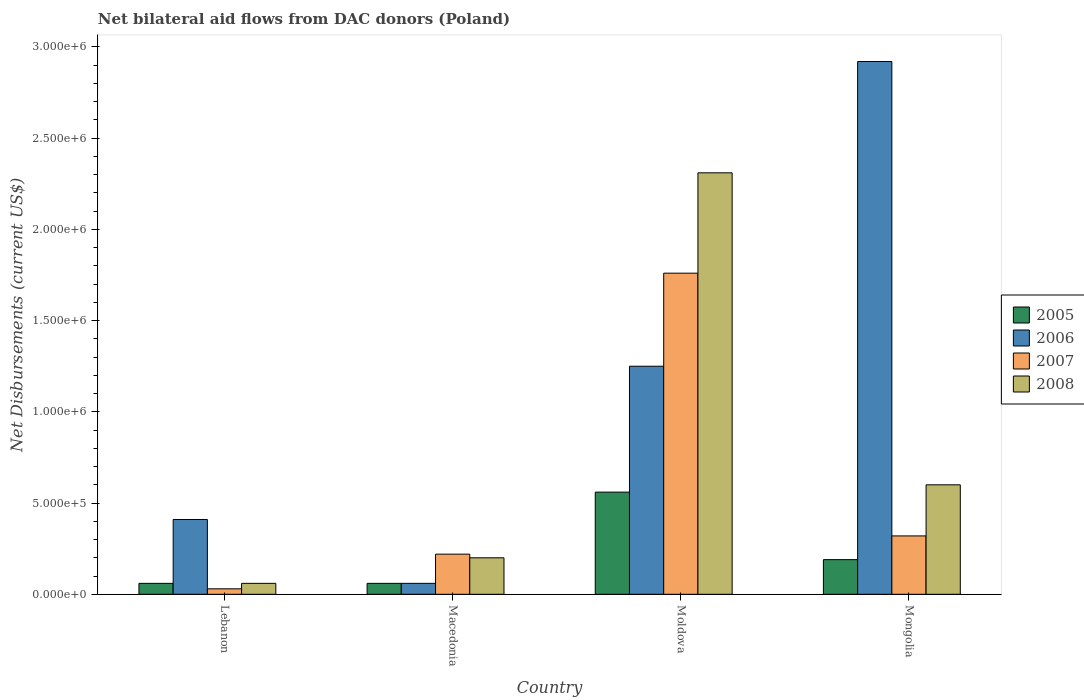How many groups of bars are there?
Offer a very short reply. 4. Are the number of bars on each tick of the X-axis equal?
Provide a succinct answer. Yes. How many bars are there on the 1st tick from the right?
Provide a short and direct response. 4. What is the label of the 3rd group of bars from the left?
Keep it short and to the point. Moldova. What is the net bilateral aid flows in 2008 in Macedonia?
Keep it short and to the point. 2.00e+05. Across all countries, what is the maximum net bilateral aid flows in 2007?
Your answer should be very brief. 1.76e+06. In which country was the net bilateral aid flows in 2008 maximum?
Provide a short and direct response. Moldova. In which country was the net bilateral aid flows in 2007 minimum?
Give a very brief answer. Lebanon. What is the total net bilateral aid flows in 2008 in the graph?
Your response must be concise. 3.17e+06. What is the difference between the net bilateral aid flows in 2005 in Lebanon and that in Moldova?
Provide a short and direct response. -5.00e+05. What is the difference between the net bilateral aid flows in 2006 in Moldova and the net bilateral aid flows in 2007 in Lebanon?
Make the answer very short. 1.22e+06. What is the average net bilateral aid flows in 2005 per country?
Provide a short and direct response. 2.18e+05. What is the difference between the net bilateral aid flows of/in 2008 and net bilateral aid flows of/in 2007 in Moldova?
Give a very brief answer. 5.50e+05. In how many countries, is the net bilateral aid flows in 2005 greater than 1800000 US$?
Your response must be concise. 0. What is the ratio of the net bilateral aid flows in 2005 in Macedonia to that in Mongolia?
Your answer should be very brief. 0.32. Is the difference between the net bilateral aid flows in 2008 in Macedonia and Mongolia greater than the difference between the net bilateral aid flows in 2007 in Macedonia and Mongolia?
Make the answer very short. No. What is the difference between the highest and the second highest net bilateral aid flows in 2008?
Your answer should be compact. 2.11e+06. What is the difference between the highest and the lowest net bilateral aid flows in 2006?
Provide a succinct answer. 2.86e+06. In how many countries, is the net bilateral aid flows in 2008 greater than the average net bilateral aid flows in 2008 taken over all countries?
Offer a terse response. 1. Is the sum of the net bilateral aid flows in 2005 in Moldova and Mongolia greater than the maximum net bilateral aid flows in 2008 across all countries?
Make the answer very short. No. Is it the case that in every country, the sum of the net bilateral aid flows in 2008 and net bilateral aid flows in 2006 is greater than the sum of net bilateral aid flows in 2005 and net bilateral aid flows in 2007?
Provide a succinct answer. No. Is it the case that in every country, the sum of the net bilateral aid flows in 2005 and net bilateral aid flows in 2008 is greater than the net bilateral aid flows in 2007?
Your response must be concise. Yes. Are all the bars in the graph horizontal?
Offer a very short reply. No. Does the graph contain any zero values?
Provide a short and direct response. No. Does the graph contain grids?
Your answer should be compact. No. How many legend labels are there?
Provide a succinct answer. 4. What is the title of the graph?
Ensure brevity in your answer.  Net bilateral aid flows from DAC donors (Poland). Does "1986" appear as one of the legend labels in the graph?
Offer a very short reply. No. What is the label or title of the X-axis?
Your answer should be very brief. Country. What is the label or title of the Y-axis?
Your response must be concise. Net Disbursements (current US$). What is the Net Disbursements (current US$) in 2006 in Lebanon?
Your response must be concise. 4.10e+05. What is the Net Disbursements (current US$) of 2007 in Lebanon?
Give a very brief answer. 3.00e+04. What is the Net Disbursements (current US$) of 2005 in Macedonia?
Your answer should be compact. 6.00e+04. What is the Net Disbursements (current US$) of 2007 in Macedonia?
Provide a succinct answer. 2.20e+05. What is the Net Disbursements (current US$) of 2005 in Moldova?
Provide a succinct answer. 5.60e+05. What is the Net Disbursements (current US$) of 2006 in Moldova?
Ensure brevity in your answer.  1.25e+06. What is the Net Disbursements (current US$) of 2007 in Moldova?
Give a very brief answer. 1.76e+06. What is the Net Disbursements (current US$) in 2008 in Moldova?
Offer a very short reply. 2.31e+06. What is the Net Disbursements (current US$) in 2006 in Mongolia?
Give a very brief answer. 2.92e+06. What is the Net Disbursements (current US$) of 2007 in Mongolia?
Make the answer very short. 3.20e+05. What is the Net Disbursements (current US$) of 2008 in Mongolia?
Your response must be concise. 6.00e+05. Across all countries, what is the maximum Net Disbursements (current US$) in 2005?
Offer a terse response. 5.60e+05. Across all countries, what is the maximum Net Disbursements (current US$) of 2006?
Make the answer very short. 2.92e+06. Across all countries, what is the maximum Net Disbursements (current US$) of 2007?
Offer a terse response. 1.76e+06. Across all countries, what is the maximum Net Disbursements (current US$) in 2008?
Give a very brief answer. 2.31e+06. Across all countries, what is the minimum Net Disbursements (current US$) of 2005?
Ensure brevity in your answer.  6.00e+04. Across all countries, what is the minimum Net Disbursements (current US$) in 2006?
Your response must be concise. 6.00e+04. What is the total Net Disbursements (current US$) in 2005 in the graph?
Give a very brief answer. 8.70e+05. What is the total Net Disbursements (current US$) of 2006 in the graph?
Offer a terse response. 4.64e+06. What is the total Net Disbursements (current US$) in 2007 in the graph?
Keep it short and to the point. 2.33e+06. What is the total Net Disbursements (current US$) in 2008 in the graph?
Keep it short and to the point. 3.17e+06. What is the difference between the Net Disbursements (current US$) of 2007 in Lebanon and that in Macedonia?
Provide a succinct answer. -1.90e+05. What is the difference between the Net Disbursements (current US$) in 2008 in Lebanon and that in Macedonia?
Make the answer very short. -1.40e+05. What is the difference between the Net Disbursements (current US$) of 2005 in Lebanon and that in Moldova?
Give a very brief answer. -5.00e+05. What is the difference between the Net Disbursements (current US$) in 2006 in Lebanon and that in Moldova?
Your answer should be very brief. -8.40e+05. What is the difference between the Net Disbursements (current US$) of 2007 in Lebanon and that in Moldova?
Make the answer very short. -1.73e+06. What is the difference between the Net Disbursements (current US$) of 2008 in Lebanon and that in Moldova?
Provide a succinct answer. -2.25e+06. What is the difference between the Net Disbursements (current US$) of 2005 in Lebanon and that in Mongolia?
Offer a terse response. -1.30e+05. What is the difference between the Net Disbursements (current US$) in 2006 in Lebanon and that in Mongolia?
Keep it short and to the point. -2.51e+06. What is the difference between the Net Disbursements (current US$) in 2008 in Lebanon and that in Mongolia?
Keep it short and to the point. -5.40e+05. What is the difference between the Net Disbursements (current US$) in 2005 in Macedonia and that in Moldova?
Ensure brevity in your answer.  -5.00e+05. What is the difference between the Net Disbursements (current US$) of 2006 in Macedonia and that in Moldova?
Your answer should be compact. -1.19e+06. What is the difference between the Net Disbursements (current US$) in 2007 in Macedonia and that in Moldova?
Your answer should be very brief. -1.54e+06. What is the difference between the Net Disbursements (current US$) in 2008 in Macedonia and that in Moldova?
Keep it short and to the point. -2.11e+06. What is the difference between the Net Disbursements (current US$) in 2005 in Macedonia and that in Mongolia?
Your response must be concise. -1.30e+05. What is the difference between the Net Disbursements (current US$) in 2006 in Macedonia and that in Mongolia?
Your answer should be very brief. -2.86e+06. What is the difference between the Net Disbursements (current US$) of 2008 in Macedonia and that in Mongolia?
Your answer should be compact. -4.00e+05. What is the difference between the Net Disbursements (current US$) of 2005 in Moldova and that in Mongolia?
Offer a terse response. 3.70e+05. What is the difference between the Net Disbursements (current US$) of 2006 in Moldova and that in Mongolia?
Give a very brief answer. -1.67e+06. What is the difference between the Net Disbursements (current US$) of 2007 in Moldova and that in Mongolia?
Provide a short and direct response. 1.44e+06. What is the difference between the Net Disbursements (current US$) in 2008 in Moldova and that in Mongolia?
Your response must be concise. 1.71e+06. What is the difference between the Net Disbursements (current US$) of 2005 in Lebanon and the Net Disbursements (current US$) of 2006 in Macedonia?
Offer a very short reply. 0. What is the difference between the Net Disbursements (current US$) of 2005 in Lebanon and the Net Disbursements (current US$) of 2006 in Moldova?
Provide a short and direct response. -1.19e+06. What is the difference between the Net Disbursements (current US$) of 2005 in Lebanon and the Net Disbursements (current US$) of 2007 in Moldova?
Offer a terse response. -1.70e+06. What is the difference between the Net Disbursements (current US$) in 2005 in Lebanon and the Net Disbursements (current US$) in 2008 in Moldova?
Provide a short and direct response. -2.25e+06. What is the difference between the Net Disbursements (current US$) in 2006 in Lebanon and the Net Disbursements (current US$) in 2007 in Moldova?
Your response must be concise. -1.35e+06. What is the difference between the Net Disbursements (current US$) of 2006 in Lebanon and the Net Disbursements (current US$) of 2008 in Moldova?
Provide a short and direct response. -1.90e+06. What is the difference between the Net Disbursements (current US$) of 2007 in Lebanon and the Net Disbursements (current US$) of 2008 in Moldova?
Your answer should be compact. -2.28e+06. What is the difference between the Net Disbursements (current US$) in 2005 in Lebanon and the Net Disbursements (current US$) in 2006 in Mongolia?
Your answer should be very brief. -2.86e+06. What is the difference between the Net Disbursements (current US$) of 2005 in Lebanon and the Net Disbursements (current US$) of 2008 in Mongolia?
Provide a succinct answer. -5.40e+05. What is the difference between the Net Disbursements (current US$) in 2006 in Lebanon and the Net Disbursements (current US$) in 2008 in Mongolia?
Offer a terse response. -1.90e+05. What is the difference between the Net Disbursements (current US$) in 2007 in Lebanon and the Net Disbursements (current US$) in 2008 in Mongolia?
Offer a terse response. -5.70e+05. What is the difference between the Net Disbursements (current US$) of 2005 in Macedonia and the Net Disbursements (current US$) of 2006 in Moldova?
Keep it short and to the point. -1.19e+06. What is the difference between the Net Disbursements (current US$) of 2005 in Macedonia and the Net Disbursements (current US$) of 2007 in Moldova?
Your response must be concise. -1.70e+06. What is the difference between the Net Disbursements (current US$) of 2005 in Macedonia and the Net Disbursements (current US$) of 2008 in Moldova?
Offer a very short reply. -2.25e+06. What is the difference between the Net Disbursements (current US$) of 2006 in Macedonia and the Net Disbursements (current US$) of 2007 in Moldova?
Provide a short and direct response. -1.70e+06. What is the difference between the Net Disbursements (current US$) of 2006 in Macedonia and the Net Disbursements (current US$) of 2008 in Moldova?
Provide a short and direct response. -2.25e+06. What is the difference between the Net Disbursements (current US$) in 2007 in Macedonia and the Net Disbursements (current US$) in 2008 in Moldova?
Provide a succinct answer. -2.09e+06. What is the difference between the Net Disbursements (current US$) of 2005 in Macedonia and the Net Disbursements (current US$) of 2006 in Mongolia?
Offer a terse response. -2.86e+06. What is the difference between the Net Disbursements (current US$) of 2005 in Macedonia and the Net Disbursements (current US$) of 2007 in Mongolia?
Offer a terse response. -2.60e+05. What is the difference between the Net Disbursements (current US$) of 2005 in Macedonia and the Net Disbursements (current US$) of 2008 in Mongolia?
Ensure brevity in your answer.  -5.40e+05. What is the difference between the Net Disbursements (current US$) in 2006 in Macedonia and the Net Disbursements (current US$) in 2007 in Mongolia?
Give a very brief answer. -2.60e+05. What is the difference between the Net Disbursements (current US$) of 2006 in Macedonia and the Net Disbursements (current US$) of 2008 in Mongolia?
Ensure brevity in your answer.  -5.40e+05. What is the difference between the Net Disbursements (current US$) in 2007 in Macedonia and the Net Disbursements (current US$) in 2008 in Mongolia?
Provide a succinct answer. -3.80e+05. What is the difference between the Net Disbursements (current US$) of 2005 in Moldova and the Net Disbursements (current US$) of 2006 in Mongolia?
Ensure brevity in your answer.  -2.36e+06. What is the difference between the Net Disbursements (current US$) in 2005 in Moldova and the Net Disbursements (current US$) in 2007 in Mongolia?
Your answer should be very brief. 2.40e+05. What is the difference between the Net Disbursements (current US$) of 2006 in Moldova and the Net Disbursements (current US$) of 2007 in Mongolia?
Give a very brief answer. 9.30e+05. What is the difference between the Net Disbursements (current US$) in 2006 in Moldova and the Net Disbursements (current US$) in 2008 in Mongolia?
Offer a terse response. 6.50e+05. What is the difference between the Net Disbursements (current US$) of 2007 in Moldova and the Net Disbursements (current US$) of 2008 in Mongolia?
Keep it short and to the point. 1.16e+06. What is the average Net Disbursements (current US$) in 2005 per country?
Your answer should be compact. 2.18e+05. What is the average Net Disbursements (current US$) of 2006 per country?
Provide a short and direct response. 1.16e+06. What is the average Net Disbursements (current US$) in 2007 per country?
Make the answer very short. 5.82e+05. What is the average Net Disbursements (current US$) of 2008 per country?
Provide a succinct answer. 7.92e+05. What is the difference between the Net Disbursements (current US$) in 2005 and Net Disbursements (current US$) in 2006 in Lebanon?
Offer a very short reply. -3.50e+05. What is the difference between the Net Disbursements (current US$) in 2006 and Net Disbursements (current US$) in 2007 in Lebanon?
Your response must be concise. 3.80e+05. What is the difference between the Net Disbursements (current US$) in 2006 and Net Disbursements (current US$) in 2008 in Lebanon?
Your answer should be compact. 3.50e+05. What is the difference between the Net Disbursements (current US$) of 2005 and Net Disbursements (current US$) of 2007 in Macedonia?
Keep it short and to the point. -1.60e+05. What is the difference between the Net Disbursements (current US$) in 2005 and Net Disbursements (current US$) in 2008 in Macedonia?
Give a very brief answer. -1.40e+05. What is the difference between the Net Disbursements (current US$) of 2007 and Net Disbursements (current US$) of 2008 in Macedonia?
Your response must be concise. 2.00e+04. What is the difference between the Net Disbursements (current US$) in 2005 and Net Disbursements (current US$) in 2006 in Moldova?
Ensure brevity in your answer.  -6.90e+05. What is the difference between the Net Disbursements (current US$) of 2005 and Net Disbursements (current US$) of 2007 in Moldova?
Provide a short and direct response. -1.20e+06. What is the difference between the Net Disbursements (current US$) in 2005 and Net Disbursements (current US$) in 2008 in Moldova?
Ensure brevity in your answer.  -1.75e+06. What is the difference between the Net Disbursements (current US$) in 2006 and Net Disbursements (current US$) in 2007 in Moldova?
Make the answer very short. -5.10e+05. What is the difference between the Net Disbursements (current US$) in 2006 and Net Disbursements (current US$) in 2008 in Moldova?
Your response must be concise. -1.06e+06. What is the difference between the Net Disbursements (current US$) in 2007 and Net Disbursements (current US$) in 2008 in Moldova?
Make the answer very short. -5.50e+05. What is the difference between the Net Disbursements (current US$) in 2005 and Net Disbursements (current US$) in 2006 in Mongolia?
Your response must be concise. -2.73e+06. What is the difference between the Net Disbursements (current US$) of 2005 and Net Disbursements (current US$) of 2007 in Mongolia?
Offer a very short reply. -1.30e+05. What is the difference between the Net Disbursements (current US$) of 2005 and Net Disbursements (current US$) of 2008 in Mongolia?
Ensure brevity in your answer.  -4.10e+05. What is the difference between the Net Disbursements (current US$) of 2006 and Net Disbursements (current US$) of 2007 in Mongolia?
Your answer should be very brief. 2.60e+06. What is the difference between the Net Disbursements (current US$) in 2006 and Net Disbursements (current US$) in 2008 in Mongolia?
Make the answer very short. 2.32e+06. What is the difference between the Net Disbursements (current US$) in 2007 and Net Disbursements (current US$) in 2008 in Mongolia?
Provide a succinct answer. -2.80e+05. What is the ratio of the Net Disbursements (current US$) in 2006 in Lebanon to that in Macedonia?
Ensure brevity in your answer.  6.83. What is the ratio of the Net Disbursements (current US$) of 2007 in Lebanon to that in Macedonia?
Provide a succinct answer. 0.14. What is the ratio of the Net Disbursements (current US$) in 2005 in Lebanon to that in Moldova?
Ensure brevity in your answer.  0.11. What is the ratio of the Net Disbursements (current US$) in 2006 in Lebanon to that in Moldova?
Provide a short and direct response. 0.33. What is the ratio of the Net Disbursements (current US$) of 2007 in Lebanon to that in Moldova?
Your answer should be very brief. 0.02. What is the ratio of the Net Disbursements (current US$) in 2008 in Lebanon to that in Moldova?
Your response must be concise. 0.03. What is the ratio of the Net Disbursements (current US$) of 2005 in Lebanon to that in Mongolia?
Make the answer very short. 0.32. What is the ratio of the Net Disbursements (current US$) of 2006 in Lebanon to that in Mongolia?
Provide a short and direct response. 0.14. What is the ratio of the Net Disbursements (current US$) in 2007 in Lebanon to that in Mongolia?
Offer a very short reply. 0.09. What is the ratio of the Net Disbursements (current US$) of 2008 in Lebanon to that in Mongolia?
Keep it short and to the point. 0.1. What is the ratio of the Net Disbursements (current US$) of 2005 in Macedonia to that in Moldova?
Your response must be concise. 0.11. What is the ratio of the Net Disbursements (current US$) of 2006 in Macedonia to that in Moldova?
Your answer should be compact. 0.05. What is the ratio of the Net Disbursements (current US$) in 2008 in Macedonia to that in Moldova?
Your answer should be very brief. 0.09. What is the ratio of the Net Disbursements (current US$) in 2005 in Macedonia to that in Mongolia?
Your response must be concise. 0.32. What is the ratio of the Net Disbursements (current US$) in 2006 in Macedonia to that in Mongolia?
Your answer should be very brief. 0.02. What is the ratio of the Net Disbursements (current US$) of 2007 in Macedonia to that in Mongolia?
Your answer should be compact. 0.69. What is the ratio of the Net Disbursements (current US$) in 2005 in Moldova to that in Mongolia?
Provide a succinct answer. 2.95. What is the ratio of the Net Disbursements (current US$) in 2006 in Moldova to that in Mongolia?
Provide a succinct answer. 0.43. What is the ratio of the Net Disbursements (current US$) of 2007 in Moldova to that in Mongolia?
Provide a succinct answer. 5.5. What is the ratio of the Net Disbursements (current US$) in 2008 in Moldova to that in Mongolia?
Your response must be concise. 3.85. What is the difference between the highest and the second highest Net Disbursements (current US$) in 2005?
Your answer should be very brief. 3.70e+05. What is the difference between the highest and the second highest Net Disbursements (current US$) of 2006?
Your response must be concise. 1.67e+06. What is the difference between the highest and the second highest Net Disbursements (current US$) in 2007?
Provide a short and direct response. 1.44e+06. What is the difference between the highest and the second highest Net Disbursements (current US$) in 2008?
Your response must be concise. 1.71e+06. What is the difference between the highest and the lowest Net Disbursements (current US$) of 2005?
Your response must be concise. 5.00e+05. What is the difference between the highest and the lowest Net Disbursements (current US$) in 2006?
Your answer should be compact. 2.86e+06. What is the difference between the highest and the lowest Net Disbursements (current US$) of 2007?
Make the answer very short. 1.73e+06. What is the difference between the highest and the lowest Net Disbursements (current US$) in 2008?
Ensure brevity in your answer.  2.25e+06. 